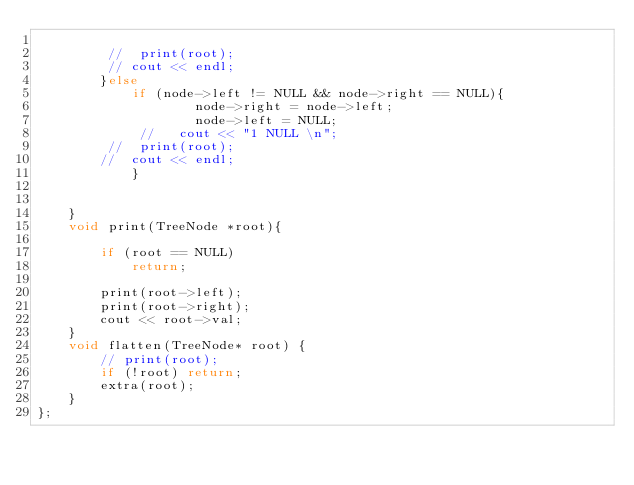<code> <loc_0><loc_0><loc_500><loc_500><_C++_>            
         //  print(root);
         // cout << endl;   
        }else
            if (node->left != NULL && node->right == NULL){                         
                    node->right = node->left;                    
                    node->left = NULL;
             //   cout << "1 NULL \n";
         //  print(root);
        //  cout << endl;   
            }
        
        
    }
    void print(TreeNode *root){
        
        if (root == NULL)
            return;
         
        print(root->left);      
        print(root->right);
        cout << root->val;
    }
    void flatten(TreeNode* root) {
        // print(root);
        if (!root) return;
        extra(root);       
    }
};</code> 